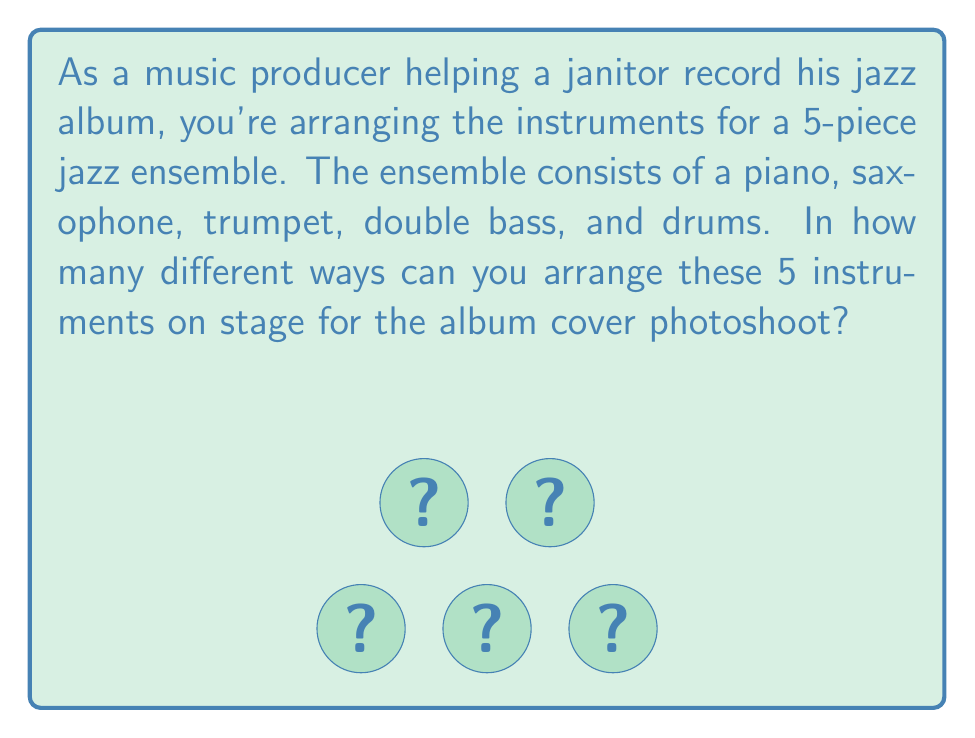Give your solution to this math problem. To solve this problem, we need to use the concept of permutations. Since we are arranging all 5 instruments and each instrument can only be used once, this is a permutation without repetition.

The formula for permutations of n distinct objects is:

$$P(n) = n!$$

Where $n!$ represents the factorial of n.

In this case, we have 5 instruments to arrange:
1. Piano
2. Saxophone
3. Trumpet
4. Double bass
5. Drums

Therefore, $n = 5$

Let's calculate step-by-step:

$$\begin{align}
P(5) &= 5! \\
&= 5 \times 4 \times 3 \times 2 \times 1 \\
&= 120
\end{align}$$

This means there are 120 different ways to arrange the 5 instruments on stage for the album cover photoshoot.
Answer: 120 